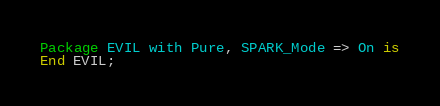<code> <loc_0><loc_0><loc_500><loc_500><_Ada_>Package EVIL with Pure, SPARK_Mode => On is
End EVIL;
</code> 